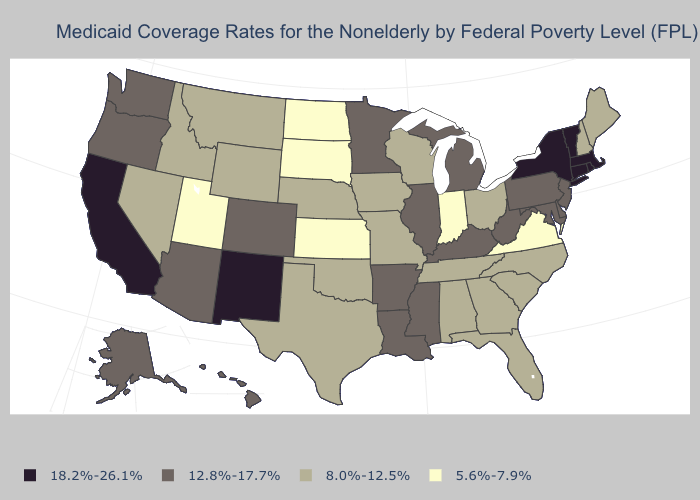Does New Jersey have a lower value than Oregon?
Concise answer only. No. Does the map have missing data?
Answer briefly. No. Among the states that border Wyoming , does Colorado have the highest value?
Quick response, please. Yes. Is the legend a continuous bar?
Write a very short answer. No. Among the states that border Connecticut , which have the highest value?
Give a very brief answer. Massachusetts, New York, Rhode Island. Name the states that have a value in the range 8.0%-12.5%?
Be succinct. Alabama, Florida, Georgia, Idaho, Iowa, Maine, Missouri, Montana, Nebraska, Nevada, New Hampshire, North Carolina, Ohio, Oklahoma, South Carolina, Tennessee, Texas, Wisconsin, Wyoming. Does the map have missing data?
Short answer required. No. Name the states that have a value in the range 8.0%-12.5%?
Keep it brief. Alabama, Florida, Georgia, Idaho, Iowa, Maine, Missouri, Montana, Nebraska, Nevada, New Hampshire, North Carolina, Ohio, Oklahoma, South Carolina, Tennessee, Texas, Wisconsin, Wyoming. Does California have the highest value in the USA?
Be succinct. Yes. What is the value of Connecticut?
Short answer required. 18.2%-26.1%. Which states hav the highest value in the Northeast?
Quick response, please. Connecticut, Massachusetts, New York, Rhode Island, Vermont. How many symbols are there in the legend?
Keep it brief. 4. Among the states that border Pennsylvania , which have the lowest value?
Quick response, please. Ohio. What is the highest value in the USA?
Be succinct. 18.2%-26.1%. Among the states that border Illinois , which have the lowest value?
Write a very short answer. Indiana. 